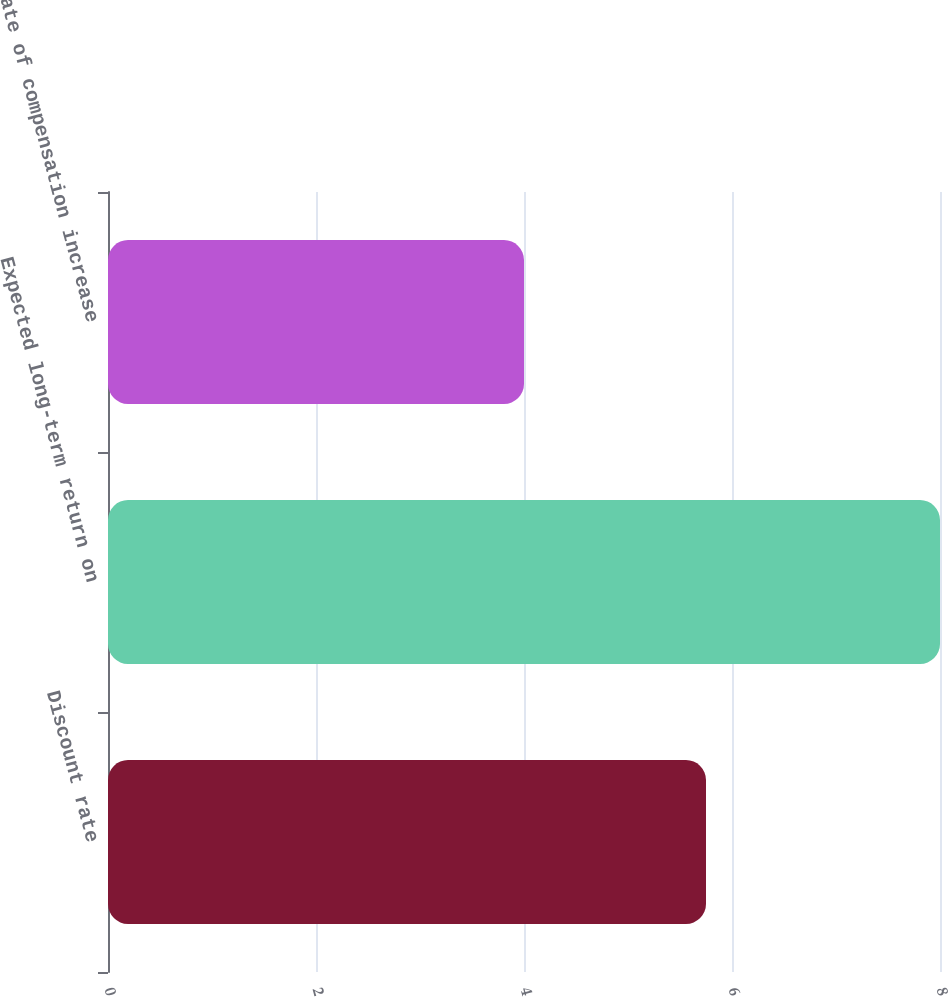Convert chart to OTSL. <chart><loc_0><loc_0><loc_500><loc_500><bar_chart><fcel>Discount rate<fcel>Expected long-term return on<fcel>Rate of compensation increase<nl><fcel>5.75<fcel>8<fcel>4<nl></chart> 